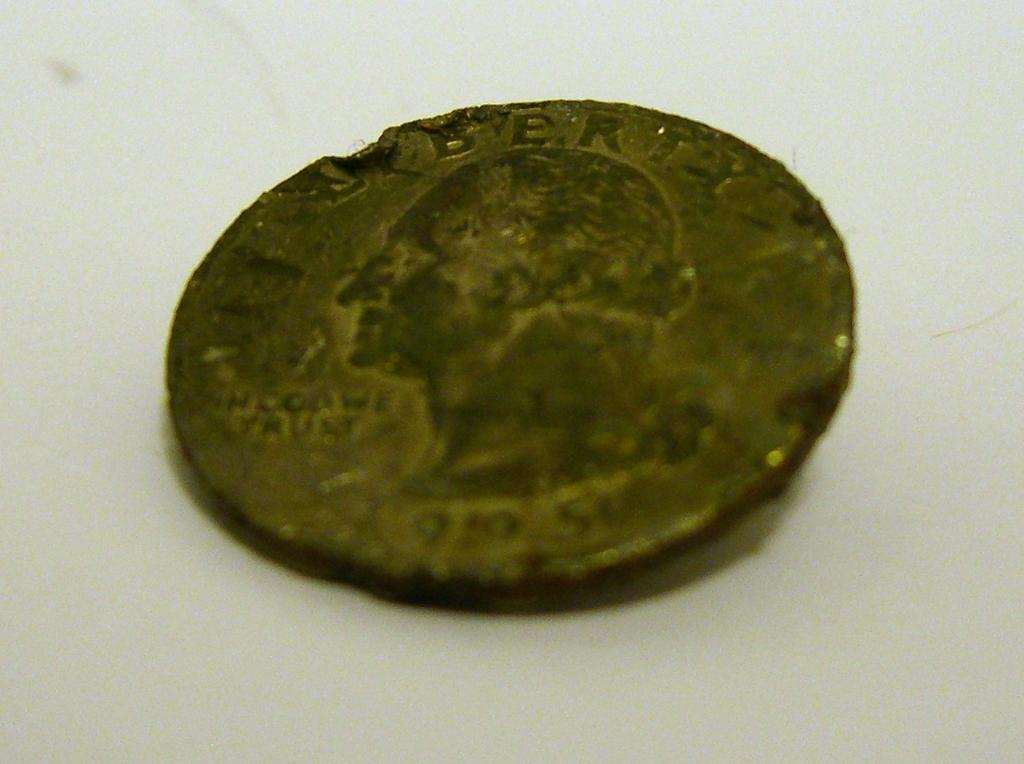<image>
Provide a brief description of the given image. An old coin has Liberty written across the top. 